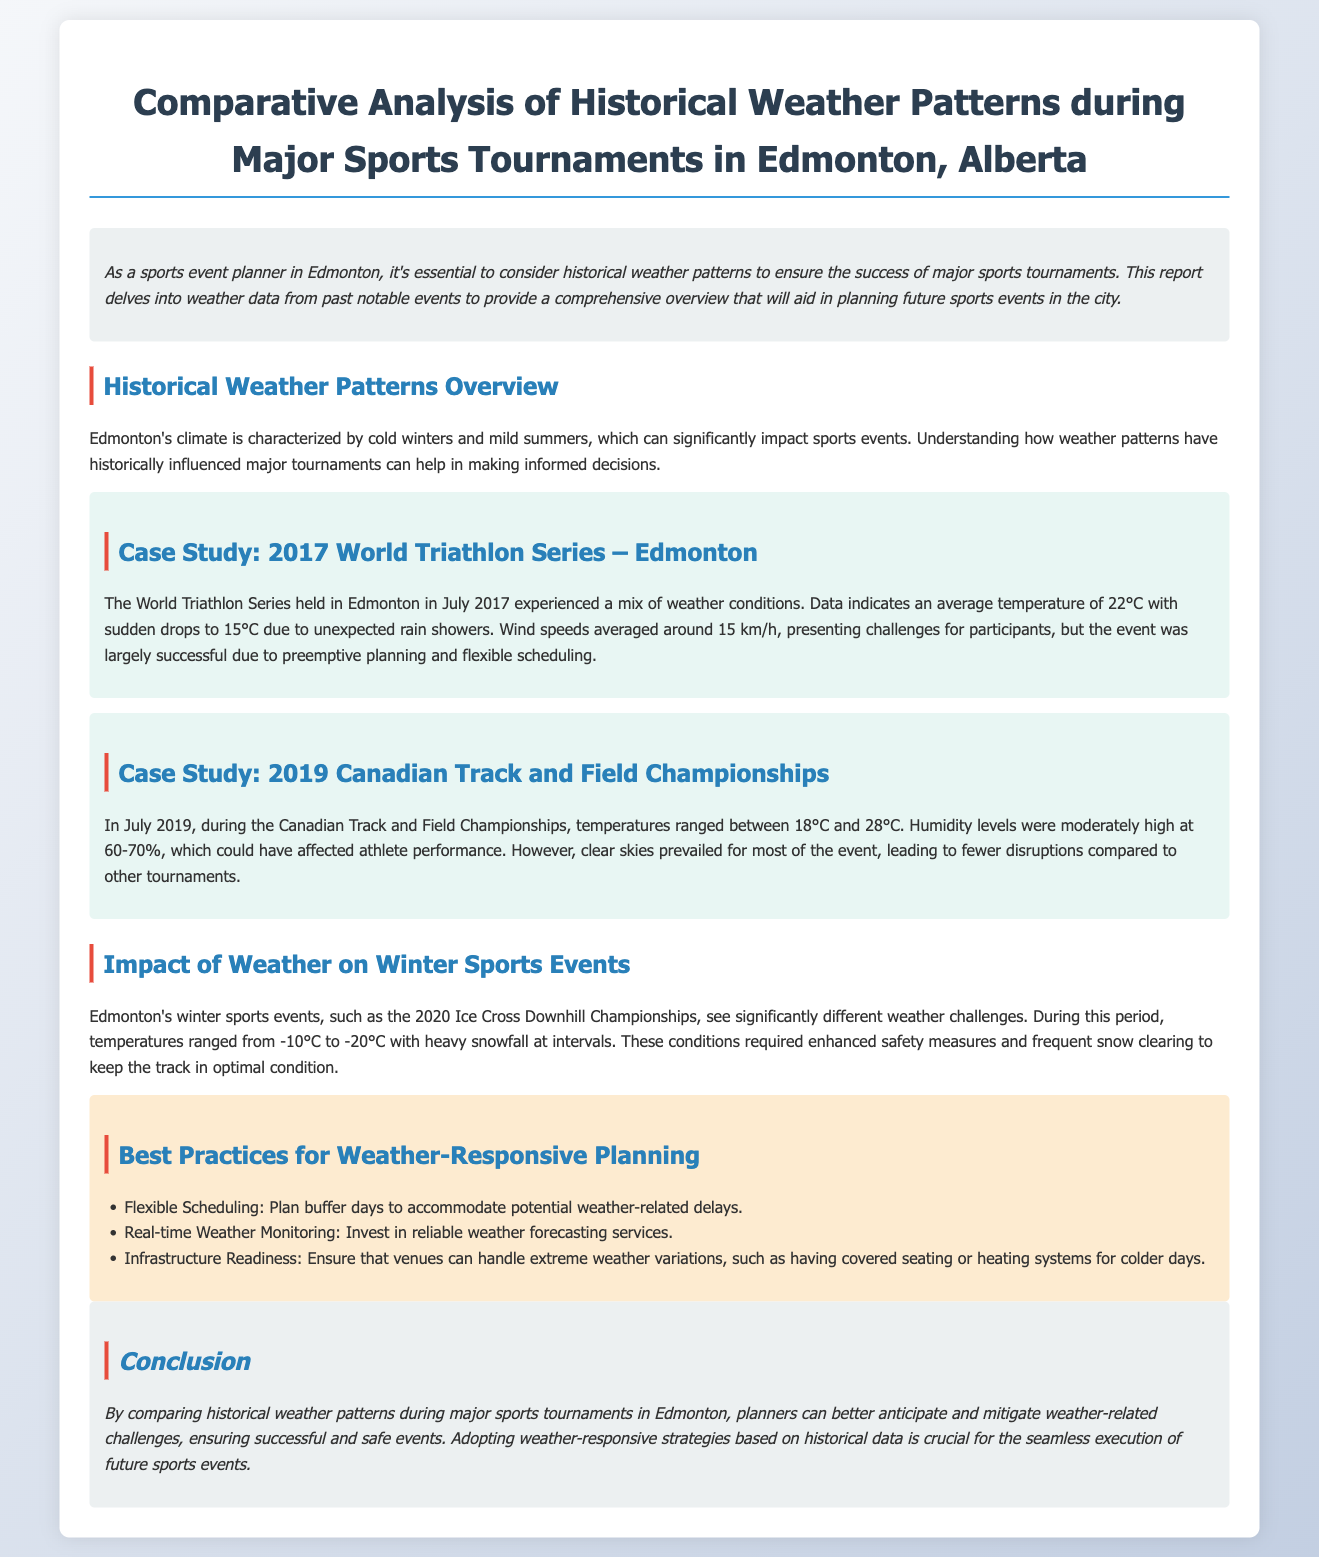What were the average temperatures during the 2017 World Triathlon Series? The average temperature was 22°C with sudden drops to 15°C due to rain showers.
Answer: 22°C What was the humidity level during the 2019 Canadian Track and Field Championships? Humidity levels were moderately high at 60-70%.
Answer: 60-70% What temperatures were experienced during the 2020 Ice Cross Downhill Championships? The temperatures ranged from -10°C to -20°C with heavy snowfall at intervals.
Answer: -10°C to -20°C What is one of the best practices for weather-responsive planning mentioned in the document? One of the best practices is to have flexible scheduling to accommodate potential weather-related delays.
Answer: Flexible Scheduling How did the weather impact participant performance in the 2019 Canadian Track and Field Championships? Moderately high humidity levels could have affected athlete performance.
Answer: Could have affected performance Which event is referenced as having significant weather challenges in winter? The event referenced is the 2020 Ice Cross Downhill Championships.
Answer: 2020 Ice Cross Downhill Championships What was one of the strategies for successful event execution discussed in the conclusion? The strategy discussed is adopting weather-responsive strategies based on historical data.
Answer: Adopting weather-responsive strategies What type of climate characterizes Edmonton's weather? Edmonton's climate is characterized by cold winters and mild summers.
Answer: Cold winters and mild summers 